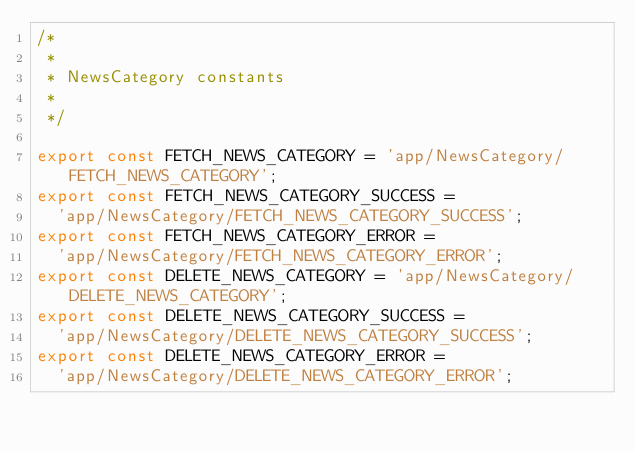<code> <loc_0><loc_0><loc_500><loc_500><_JavaScript_>/*
 *
 * NewsCategory constants
 *
 */

export const FETCH_NEWS_CATEGORY = 'app/NewsCategory/FETCH_NEWS_CATEGORY';
export const FETCH_NEWS_CATEGORY_SUCCESS =
  'app/NewsCategory/FETCH_NEWS_CATEGORY_SUCCESS';
export const FETCH_NEWS_CATEGORY_ERROR =
  'app/NewsCategory/FETCH_NEWS_CATEGORY_ERROR';
export const DELETE_NEWS_CATEGORY = 'app/NewsCategory/DELETE_NEWS_CATEGORY';
export const DELETE_NEWS_CATEGORY_SUCCESS =
  'app/NewsCategory/DELETE_NEWS_CATEGORY_SUCCESS';
export const DELETE_NEWS_CATEGORY_ERROR =
  'app/NewsCategory/DELETE_NEWS_CATEGORY_ERROR';
</code> 